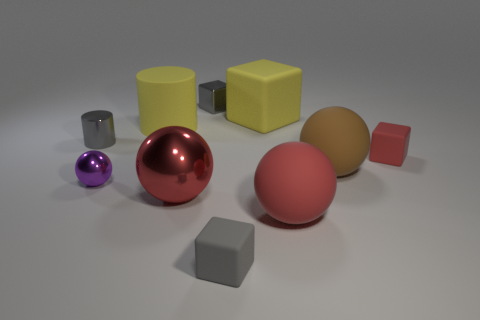Subtract all balls. How many objects are left? 6 Subtract 0 green blocks. How many objects are left? 10 Subtract all gray metallic blocks. Subtract all matte cylinders. How many objects are left? 8 Add 7 rubber spheres. How many rubber spheres are left? 9 Add 6 tiny green rubber balls. How many tiny green rubber balls exist? 6 